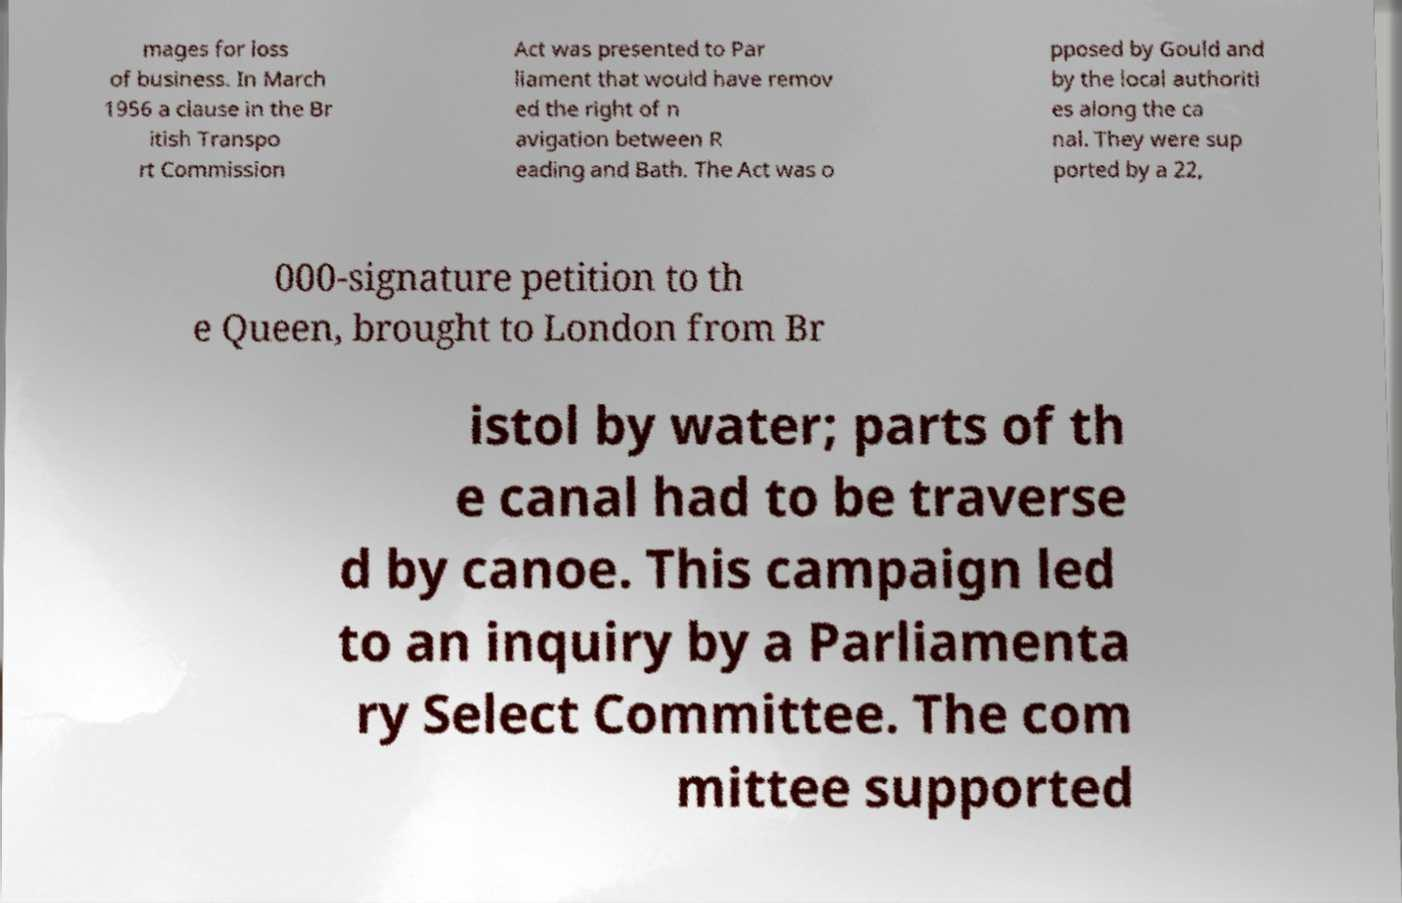Can you read and provide the text displayed in the image?This photo seems to have some interesting text. Can you extract and type it out for me? mages for loss of business. In March 1956 a clause in the Br itish Transpo rt Commission Act was presented to Par liament that would have remov ed the right of n avigation between R eading and Bath. The Act was o pposed by Gould and by the local authoriti es along the ca nal. They were sup ported by a 22, 000-signature petition to th e Queen, brought to London from Br istol by water; parts of th e canal had to be traverse d by canoe. This campaign led to an inquiry by a Parliamenta ry Select Committee. The com mittee supported 